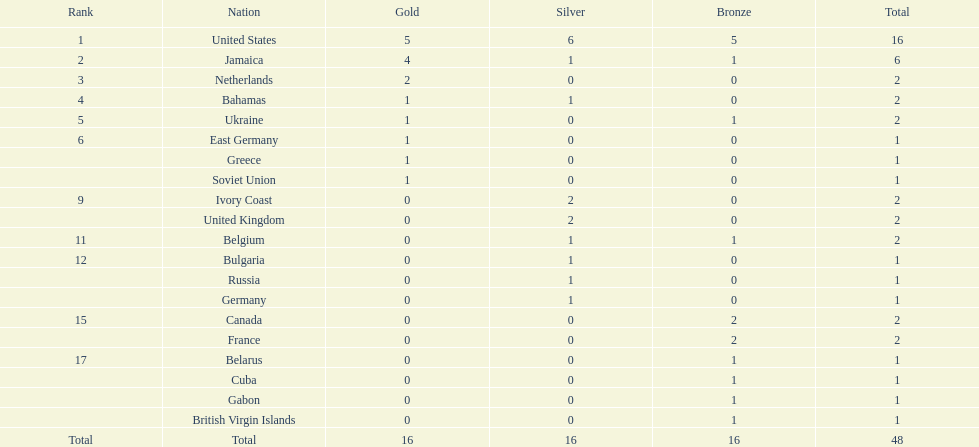Which nations secured a minimum of 3 silver medals? United States. 